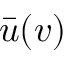Convert formula to latex. <formula><loc_0><loc_0><loc_500><loc_500>\bar { u } ( v )</formula> 